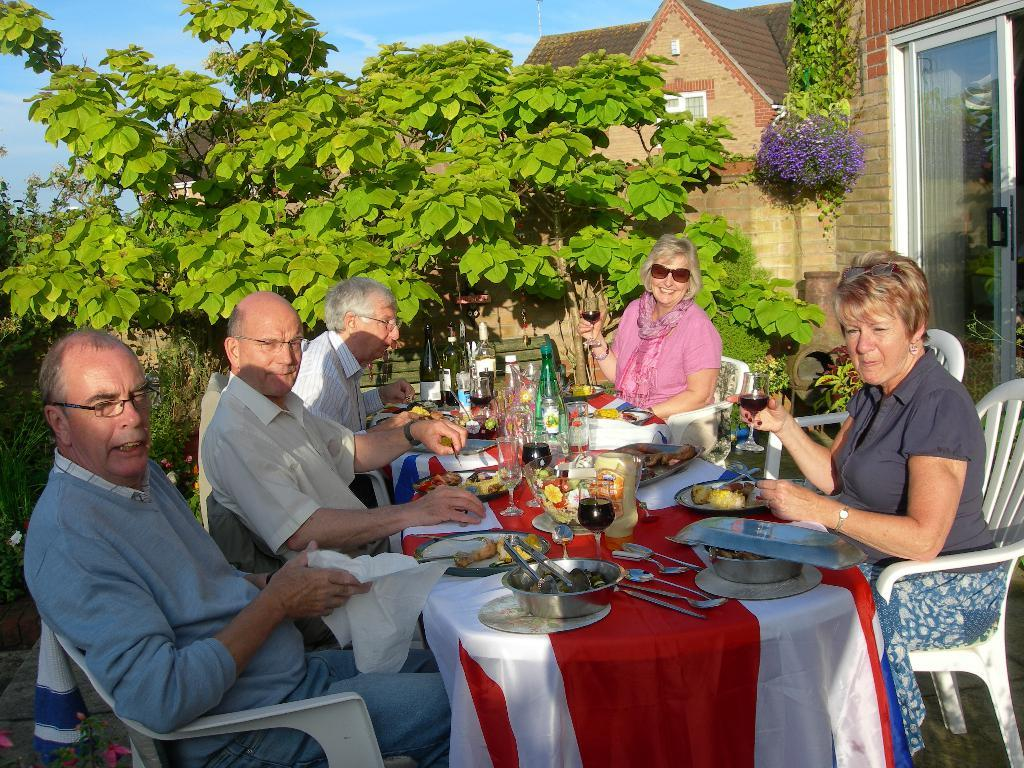How many people are in the image? There is a group of people in the image. What are the people doing in the image? The people are sitting around a table and eating food. What can be seen in the background of the image? There are trees and a building visible in the background of the image. What type of cake is Uncle John cutting in the image? There is no cake or Uncle John present in the image. What flavor of pie is being served to the people in the image? There is no mention of pie in the image; the people are eating food, but the specific type of food is not specified. 